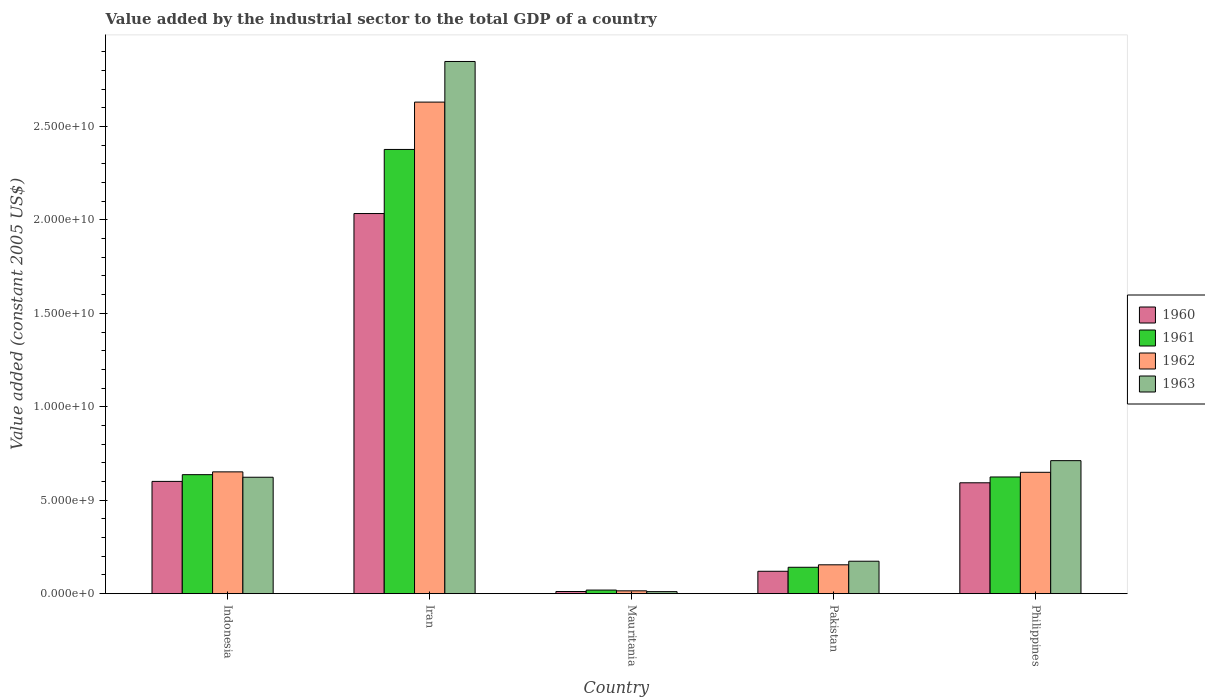How many groups of bars are there?
Make the answer very short. 5. Are the number of bars on each tick of the X-axis equal?
Ensure brevity in your answer.  Yes. What is the label of the 5th group of bars from the left?
Offer a terse response. Philippines. In how many cases, is the number of bars for a given country not equal to the number of legend labels?
Your answer should be compact. 0. What is the value added by the industrial sector in 1962 in Indonesia?
Keep it short and to the point. 6.52e+09. Across all countries, what is the maximum value added by the industrial sector in 1961?
Your answer should be compact. 2.38e+1. Across all countries, what is the minimum value added by the industrial sector in 1963?
Offer a terse response. 1.08e+08. In which country was the value added by the industrial sector in 1962 maximum?
Your response must be concise. Iran. In which country was the value added by the industrial sector in 1963 minimum?
Your response must be concise. Mauritania. What is the total value added by the industrial sector in 1961 in the graph?
Offer a terse response. 3.80e+1. What is the difference between the value added by the industrial sector in 1962 in Indonesia and that in Iran?
Your answer should be compact. -1.98e+1. What is the difference between the value added by the industrial sector in 1963 in Philippines and the value added by the industrial sector in 1960 in Iran?
Keep it short and to the point. -1.32e+1. What is the average value added by the industrial sector in 1963 per country?
Make the answer very short. 8.73e+09. What is the difference between the value added by the industrial sector of/in 1963 and value added by the industrial sector of/in 1961 in Mauritania?
Your response must be concise. -8.39e+07. In how many countries, is the value added by the industrial sector in 1961 greater than 1000000000 US$?
Offer a very short reply. 4. What is the ratio of the value added by the industrial sector in 1961 in Iran to that in Mauritania?
Provide a succinct answer. 123.7. Is the value added by the industrial sector in 1960 in Iran less than that in Philippines?
Provide a succinct answer. No. Is the difference between the value added by the industrial sector in 1963 in Pakistan and Philippines greater than the difference between the value added by the industrial sector in 1961 in Pakistan and Philippines?
Provide a succinct answer. No. What is the difference between the highest and the second highest value added by the industrial sector in 1962?
Offer a very short reply. -1.98e+1. What is the difference between the highest and the lowest value added by the industrial sector in 1963?
Ensure brevity in your answer.  2.84e+1. In how many countries, is the value added by the industrial sector in 1963 greater than the average value added by the industrial sector in 1963 taken over all countries?
Provide a succinct answer. 1. Is it the case that in every country, the sum of the value added by the industrial sector in 1960 and value added by the industrial sector in 1963 is greater than the sum of value added by the industrial sector in 1962 and value added by the industrial sector in 1961?
Make the answer very short. No. What does the 1st bar from the left in Indonesia represents?
Ensure brevity in your answer.  1960. Is it the case that in every country, the sum of the value added by the industrial sector in 1960 and value added by the industrial sector in 1962 is greater than the value added by the industrial sector in 1963?
Provide a succinct answer. Yes. How many bars are there?
Give a very brief answer. 20. What is the difference between two consecutive major ticks on the Y-axis?
Your answer should be very brief. 5.00e+09. Does the graph contain any zero values?
Your answer should be very brief. No. How are the legend labels stacked?
Ensure brevity in your answer.  Vertical. What is the title of the graph?
Keep it short and to the point. Value added by the industrial sector to the total GDP of a country. Does "2002" appear as one of the legend labels in the graph?
Your answer should be very brief. No. What is the label or title of the Y-axis?
Your answer should be very brief. Value added (constant 2005 US$). What is the Value added (constant 2005 US$) of 1960 in Indonesia?
Offer a very short reply. 6.01e+09. What is the Value added (constant 2005 US$) of 1961 in Indonesia?
Your response must be concise. 6.37e+09. What is the Value added (constant 2005 US$) of 1962 in Indonesia?
Make the answer very short. 6.52e+09. What is the Value added (constant 2005 US$) in 1963 in Indonesia?
Give a very brief answer. 6.23e+09. What is the Value added (constant 2005 US$) in 1960 in Iran?
Offer a very short reply. 2.03e+1. What is the Value added (constant 2005 US$) of 1961 in Iran?
Give a very brief answer. 2.38e+1. What is the Value added (constant 2005 US$) of 1962 in Iran?
Give a very brief answer. 2.63e+1. What is the Value added (constant 2005 US$) in 1963 in Iran?
Your response must be concise. 2.85e+1. What is the Value added (constant 2005 US$) in 1960 in Mauritania?
Give a very brief answer. 1.15e+08. What is the Value added (constant 2005 US$) in 1961 in Mauritania?
Your response must be concise. 1.92e+08. What is the Value added (constant 2005 US$) in 1962 in Mauritania?
Your answer should be compact. 1.51e+08. What is the Value added (constant 2005 US$) in 1963 in Mauritania?
Your response must be concise. 1.08e+08. What is the Value added (constant 2005 US$) in 1960 in Pakistan?
Provide a short and direct response. 1.20e+09. What is the Value added (constant 2005 US$) in 1961 in Pakistan?
Provide a short and direct response. 1.41e+09. What is the Value added (constant 2005 US$) of 1962 in Pakistan?
Provide a short and direct response. 1.54e+09. What is the Value added (constant 2005 US$) of 1963 in Pakistan?
Give a very brief answer. 1.74e+09. What is the Value added (constant 2005 US$) in 1960 in Philippines?
Offer a terse response. 5.93e+09. What is the Value added (constant 2005 US$) in 1961 in Philippines?
Provide a short and direct response. 6.24e+09. What is the Value added (constant 2005 US$) of 1962 in Philippines?
Offer a very short reply. 6.49e+09. What is the Value added (constant 2005 US$) of 1963 in Philippines?
Ensure brevity in your answer.  7.12e+09. Across all countries, what is the maximum Value added (constant 2005 US$) of 1960?
Your answer should be very brief. 2.03e+1. Across all countries, what is the maximum Value added (constant 2005 US$) in 1961?
Your response must be concise. 2.38e+1. Across all countries, what is the maximum Value added (constant 2005 US$) in 1962?
Keep it short and to the point. 2.63e+1. Across all countries, what is the maximum Value added (constant 2005 US$) in 1963?
Offer a very short reply. 2.85e+1. Across all countries, what is the minimum Value added (constant 2005 US$) in 1960?
Give a very brief answer. 1.15e+08. Across all countries, what is the minimum Value added (constant 2005 US$) in 1961?
Provide a succinct answer. 1.92e+08. Across all countries, what is the minimum Value added (constant 2005 US$) in 1962?
Your response must be concise. 1.51e+08. Across all countries, what is the minimum Value added (constant 2005 US$) in 1963?
Provide a short and direct response. 1.08e+08. What is the total Value added (constant 2005 US$) of 1960 in the graph?
Your answer should be very brief. 3.36e+1. What is the total Value added (constant 2005 US$) of 1961 in the graph?
Your answer should be very brief. 3.80e+1. What is the total Value added (constant 2005 US$) in 1962 in the graph?
Offer a very short reply. 4.10e+1. What is the total Value added (constant 2005 US$) in 1963 in the graph?
Offer a terse response. 4.37e+1. What is the difference between the Value added (constant 2005 US$) in 1960 in Indonesia and that in Iran?
Keep it short and to the point. -1.43e+1. What is the difference between the Value added (constant 2005 US$) in 1961 in Indonesia and that in Iran?
Give a very brief answer. -1.74e+1. What is the difference between the Value added (constant 2005 US$) of 1962 in Indonesia and that in Iran?
Make the answer very short. -1.98e+1. What is the difference between the Value added (constant 2005 US$) of 1963 in Indonesia and that in Iran?
Offer a terse response. -2.22e+1. What is the difference between the Value added (constant 2005 US$) in 1960 in Indonesia and that in Mauritania?
Offer a terse response. 5.89e+09. What is the difference between the Value added (constant 2005 US$) in 1961 in Indonesia and that in Mauritania?
Your response must be concise. 6.17e+09. What is the difference between the Value added (constant 2005 US$) of 1962 in Indonesia and that in Mauritania?
Offer a very short reply. 6.37e+09. What is the difference between the Value added (constant 2005 US$) in 1963 in Indonesia and that in Mauritania?
Your answer should be very brief. 6.12e+09. What is the difference between the Value added (constant 2005 US$) of 1960 in Indonesia and that in Pakistan?
Give a very brief answer. 4.81e+09. What is the difference between the Value added (constant 2005 US$) in 1961 in Indonesia and that in Pakistan?
Ensure brevity in your answer.  4.96e+09. What is the difference between the Value added (constant 2005 US$) in 1962 in Indonesia and that in Pakistan?
Provide a short and direct response. 4.97e+09. What is the difference between the Value added (constant 2005 US$) in 1963 in Indonesia and that in Pakistan?
Offer a terse response. 4.49e+09. What is the difference between the Value added (constant 2005 US$) of 1960 in Indonesia and that in Philippines?
Offer a very short reply. 7.44e+07. What is the difference between the Value added (constant 2005 US$) in 1961 in Indonesia and that in Philippines?
Your answer should be compact. 1.23e+08. What is the difference between the Value added (constant 2005 US$) in 1962 in Indonesia and that in Philippines?
Provide a short and direct response. 2.37e+07. What is the difference between the Value added (constant 2005 US$) of 1963 in Indonesia and that in Philippines?
Your response must be concise. -8.88e+08. What is the difference between the Value added (constant 2005 US$) in 1960 in Iran and that in Mauritania?
Your answer should be very brief. 2.02e+1. What is the difference between the Value added (constant 2005 US$) of 1961 in Iran and that in Mauritania?
Provide a short and direct response. 2.36e+1. What is the difference between the Value added (constant 2005 US$) of 1962 in Iran and that in Mauritania?
Your response must be concise. 2.62e+1. What is the difference between the Value added (constant 2005 US$) of 1963 in Iran and that in Mauritania?
Your answer should be compact. 2.84e+1. What is the difference between the Value added (constant 2005 US$) of 1960 in Iran and that in Pakistan?
Offer a very short reply. 1.91e+1. What is the difference between the Value added (constant 2005 US$) of 1961 in Iran and that in Pakistan?
Provide a short and direct response. 2.24e+1. What is the difference between the Value added (constant 2005 US$) in 1962 in Iran and that in Pakistan?
Provide a short and direct response. 2.48e+1. What is the difference between the Value added (constant 2005 US$) in 1963 in Iran and that in Pakistan?
Offer a very short reply. 2.67e+1. What is the difference between the Value added (constant 2005 US$) in 1960 in Iran and that in Philippines?
Provide a short and direct response. 1.44e+1. What is the difference between the Value added (constant 2005 US$) of 1961 in Iran and that in Philippines?
Your answer should be compact. 1.75e+1. What is the difference between the Value added (constant 2005 US$) of 1962 in Iran and that in Philippines?
Keep it short and to the point. 1.98e+1. What is the difference between the Value added (constant 2005 US$) of 1963 in Iran and that in Philippines?
Offer a terse response. 2.14e+1. What is the difference between the Value added (constant 2005 US$) in 1960 in Mauritania and that in Pakistan?
Your response must be concise. -1.08e+09. What is the difference between the Value added (constant 2005 US$) of 1961 in Mauritania and that in Pakistan?
Your answer should be very brief. -1.22e+09. What is the difference between the Value added (constant 2005 US$) of 1962 in Mauritania and that in Pakistan?
Your answer should be very brief. -1.39e+09. What is the difference between the Value added (constant 2005 US$) in 1963 in Mauritania and that in Pakistan?
Your answer should be very brief. -1.63e+09. What is the difference between the Value added (constant 2005 US$) of 1960 in Mauritania and that in Philippines?
Provide a succinct answer. -5.82e+09. What is the difference between the Value added (constant 2005 US$) in 1961 in Mauritania and that in Philippines?
Offer a very short reply. -6.05e+09. What is the difference between the Value added (constant 2005 US$) in 1962 in Mauritania and that in Philippines?
Provide a succinct answer. -6.34e+09. What is the difference between the Value added (constant 2005 US$) of 1963 in Mauritania and that in Philippines?
Offer a terse response. -7.01e+09. What is the difference between the Value added (constant 2005 US$) in 1960 in Pakistan and that in Philippines?
Give a very brief answer. -4.73e+09. What is the difference between the Value added (constant 2005 US$) of 1961 in Pakistan and that in Philippines?
Offer a very short reply. -4.83e+09. What is the difference between the Value added (constant 2005 US$) in 1962 in Pakistan and that in Philippines?
Offer a terse response. -4.95e+09. What is the difference between the Value added (constant 2005 US$) in 1963 in Pakistan and that in Philippines?
Offer a very short reply. -5.38e+09. What is the difference between the Value added (constant 2005 US$) in 1960 in Indonesia and the Value added (constant 2005 US$) in 1961 in Iran?
Give a very brief answer. -1.78e+1. What is the difference between the Value added (constant 2005 US$) in 1960 in Indonesia and the Value added (constant 2005 US$) in 1962 in Iran?
Your answer should be very brief. -2.03e+1. What is the difference between the Value added (constant 2005 US$) of 1960 in Indonesia and the Value added (constant 2005 US$) of 1963 in Iran?
Keep it short and to the point. -2.25e+1. What is the difference between the Value added (constant 2005 US$) in 1961 in Indonesia and the Value added (constant 2005 US$) in 1962 in Iran?
Provide a short and direct response. -1.99e+1. What is the difference between the Value added (constant 2005 US$) in 1961 in Indonesia and the Value added (constant 2005 US$) in 1963 in Iran?
Your response must be concise. -2.21e+1. What is the difference between the Value added (constant 2005 US$) in 1962 in Indonesia and the Value added (constant 2005 US$) in 1963 in Iran?
Offer a terse response. -2.20e+1. What is the difference between the Value added (constant 2005 US$) in 1960 in Indonesia and the Value added (constant 2005 US$) in 1961 in Mauritania?
Offer a terse response. 5.81e+09. What is the difference between the Value added (constant 2005 US$) of 1960 in Indonesia and the Value added (constant 2005 US$) of 1962 in Mauritania?
Give a very brief answer. 5.86e+09. What is the difference between the Value added (constant 2005 US$) of 1960 in Indonesia and the Value added (constant 2005 US$) of 1963 in Mauritania?
Provide a succinct answer. 5.90e+09. What is the difference between the Value added (constant 2005 US$) in 1961 in Indonesia and the Value added (constant 2005 US$) in 1962 in Mauritania?
Give a very brief answer. 6.22e+09. What is the difference between the Value added (constant 2005 US$) of 1961 in Indonesia and the Value added (constant 2005 US$) of 1963 in Mauritania?
Make the answer very short. 6.26e+09. What is the difference between the Value added (constant 2005 US$) in 1962 in Indonesia and the Value added (constant 2005 US$) in 1963 in Mauritania?
Provide a succinct answer. 6.41e+09. What is the difference between the Value added (constant 2005 US$) of 1960 in Indonesia and the Value added (constant 2005 US$) of 1961 in Pakistan?
Provide a short and direct response. 4.60e+09. What is the difference between the Value added (constant 2005 US$) of 1960 in Indonesia and the Value added (constant 2005 US$) of 1962 in Pakistan?
Make the answer very short. 4.46e+09. What is the difference between the Value added (constant 2005 US$) in 1960 in Indonesia and the Value added (constant 2005 US$) in 1963 in Pakistan?
Offer a very short reply. 4.27e+09. What is the difference between the Value added (constant 2005 US$) in 1961 in Indonesia and the Value added (constant 2005 US$) in 1962 in Pakistan?
Offer a very short reply. 4.82e+09. What is the difference between the Value added (constant 2005 US$) of 1961 in Indonesia and the Value added (constant 2005 US$) of 1963 in Pakistan?
Provide a succinct answer. 4.63e+09. What is the difference between the Value added (constant 2005 US$) of 1962 in Indonesia and the Value added (constant 2005 US$) of 1963 in Pakistan?
Provide a short and direct response. 4.78e+09. What is the difference between the Value added (constant 2005 US$) in 1960 in Indonesia and the Value added (constant 2005 US$) in 1961 in Philippines?
Ensure brevity in your answer.  -2.37e+08. What is the difference between the Value added (constant 2005 US$) of 1960 in Indonesia and the Value added (constant 2005 US$) of 1962 in Philippines?
Offer a very short reply. -4.86e+08. What is the difference between the Value added (constant 2005 US$) of 1960 in Indonesia and the Value added (constant 2005 US$) of 1963 in Philippines?
Provide a succinct answer. -1.11e+09. What is the difference between the Value added (constant 2005 US$) of 1961 in Indonesia and the Value added (constant 2005 US$) of 1962 in Philippines?
Give a very brief answer. -1.26e+08. What is the difference between the Value added (constant 2005 US$) of 1961 in Indonesia and the Value added (constant 2005 US$) of 1963 in Philippines?
Give a very brief answer. -7.50e+08. What is the difference between the Value added (constant 2005 US$) of 1962 in Indonesia and the Value added (constant 2005 US$) of 1963 in Philippines?
Your response must be concise. -6.01e+08. What is the difference between the Value added (constant 2005 US$) in 1960 in Iran and the Value added (constant 2005 US$) in 1961 in Mauritania?
Your response must be concise. 2.01e+1. What is the difference between the Value added (constant 2005 US$) of 1960 in Iran and the Value added (constant 2005 US$) of 1962 in Mauritania?
Your response must be concise. 2.02e+1. What is the difference between the Value added (constant 2005 US$) of 1960 in Iran and the Value added (constant 2005 US$) of 1963 in Mauritania?
Keep it short and to the point. 2.02e+1. What is the difference between the Value added (constant 2005 US$) in 1961 in Iran and the Value added (constant 2005 US$) in 1962 in Mauritania?
Ensure brevity in your answer.  2.36e+1. What is the difference between the Value added (constant 2005 US$) of 1961 in Iran and the Value added (constant 2005 US$) of 1963 in Mauritania?
Offer a very short reply. 2.37e+1. What is the difference between the Value added (constant 2005 US$) of 1962 in Iran and the Value added (constant 2005 US$) of 1963 in Mauritania?
Provide a short and direct response. 2.62e+1. What is the difference between the Value added (constant 2005 US$) of 1960 in Iran and the Value added (constant 2005 US$) of 1961 in Pakistan?
Offer a very short reply. 1.89e+1. What is the difference between the Value added (constant 2005 US$) in 1960 in Iran and the Value added (constant 2005 US$) in 1962 in Pakistan?
Offer a very short reply. 1.88e+1. What is the difference between the Value added (constant 2005 US$) of 1960 in Iran and the Value added (constant 2005 US$) of 1963 in Pakistan?
Keep it short and to the point. 1.86e+1. What is the difference between the Value added (constant 2005 US$) in 1961 in Iran and the Value added (constant 2005 US$) in 1962 in Pakistan?
Your answer should be compact. 2.22e+1. What is the difference between the Value added (constant 2005 US$) in 1961 in Iran and the Value added (constant 2005 US$) in 1963 in Pakistan?
Offer a terse response. 2.20e+1. What is the difference between the Value added (constant 2005 US$) in 1962 in Iran and the Value added (constant 2005 US$) in 1963 in Pakistan?
Your response must be concise. 2.46e+1. What is the difference between the Value added (constant 2005 US$) in 1960 in Iran and the Value added (constant 2005 US$) in 1961 in Philippines?
Make the answer very short. 1.41e+1. What is the difference between the Value added (constant 2005 US$) of 1960 in Iran and the Value added (constant 2005 US$) of 1962 in Philippines?
Offer a very short reply. 1.38e+1. What is the difference between the Value added (constant 2005 US$) in 1960 in Iran and the Value added (constant 2005 US$) in 1963 in Philippines?
Provide a succinct answer. 1.32e+1. What is the difference between the Value added (constant 2005 US$) of 1961 in Iran and the Value added (constant 2005 US$) of 1962 in Philippines?
Your response must be concise. 1.73e+1. What is the difference between the Value added (constant 2005 US$) in 1961 in Iran and the Value added (constant 2005 US$) in 1963 in Philippines?
Provide a short and direct response. 1.67e+1. What is the difference between the Value added (constant 2005 US$) of 1962 in Iran and the Value added (constant 2005 US$) of 1963 in Philippines?
Your answer should be compact. 1.92e+1. What is the difference between the Value added (constant 2005 US$) of 1960 in Mauritania and the Value added (constant 2005 US$) of 1961 in Pakistan?
Offer a very short reply. -1.30e+09. What is the difference between the Value added (constant 2005 US$) of 1960 in Mauritania and the Value added (constant 2005 US$) of 1962 in Pakistan?
Your answer should be very brief. -1.43e+09. What is the difference between the Value added (constant 2005 US$) in 1960 in Mauritania and the Value added (constant 2005 US$) in 1963 in Pakistan?
Ensure brevity in your answer.  -1.62e+09. What is the difference between the Value added (constant 2005 US$) in 1961 in Mauritania and the Value added (constant 2005 US$) in 1962 in Pakistan?
Ensure brevity in your answer.  -1.35e+09. What is the difference between the Value added (constant 2005 US$) in 1961 in Mauritania and the Value added (constant 2005 US$) in 1963 in Pakistan?
Offer a terse response. -1.54e+09. What is the difference between the Value added (constant 2005 US$) in 1962 in Mauritania and the Value added (constant 2005 US$) in 1963 in Pakistan?
Your response must be concise. -1.58e+09. What is the difference between the Value added (constant 2005 US$) in 1960 in Mauritania and the Value added (constant 2005 US$) in 1961 in Philippines?
Keep it short and to the point. -6.13e+09. What is the difference between the Value added (constant 2005 US$) of 1960 in Mauritania and the Value added (constant 2005 US$) of 1962 in Philippines?
Offer a terse response. -6.38e+09. What is the difference between the Value added (constant 2005 US$) of 1960 in Mauritania and the Value added (constant 2005 US$) of 1963 in Philippines?
Make the answer very short. -7.00e+09. What is the difference between the Value added (constant 2005 US$) of 1961 in Mauritania and the Value added (constant 2005 US$) of 1962 in Philippines?
Your answer should be very brief. -6.30e+09. What is the difference between the Value added (constant 2005 US$) of 1961 in Mauritania and the Value added (constant 2005 US$) of 1963 in Philippines?
Offer a terse response. -6.93e+09. What is the difference between the Value added (constant 2005 US$) of 1962 in Mauritania and the Value added (constant 2005 US$) of 1963 in Philippines?
Provide a short and direct response. -6.97e+09. What is the difference between the Value added (constant 2005 US$) of 1960 in Pakistan and the Value added (constant 2005 US$) of 1961 in Philippines?
Offer a very short reply. -5.05e+09. What is the difference between the Value added (constant 2005 US$) of 1960 in Pakistan and the Value added (constant 2005 US$) of 1962 in Philippines?
Provide a short and direct response. -5.30e+09. What is the difference between the Value added (constant 2005 US$) in 1960 in Pakistan and the Value added (constant 2005 US$) in 1963 in Philippines?
Provide a succinct answer. -5.92e+09. What is the difference between the Value added (constant 2005 US$) in 1961 in Pakistan and the Value added (constant 2005 US$) in 1962 in Philippines?
Offer a terse response. -5.08e+09. What is the difference between the Value added (constant 2005 US$) in 1961 in Pakistan and the Value added (constant 2005 US$) in 1963 in Philippines?
Your response must be concise. -5.71e+09. What is the difference between the Value added (constant 2005 US$) in 1962 in Pakistan and the Value added (constant 2005 US$) in 1963 in Philippines?
Your answer should be compact. -5.57e+09. What is the average Value added (constant 2005 US$) in 1960 per country?
Provide a short and direct response. 6.72e+09. What is the average Value added (constant 2005 US$) in 1961 per country?
Give a very brief answer. 7.60e+09. What is the average Value added (constant 2005 US$) of 1962 per country?
Your answer should be very brief. 8.20e+09. What is the average Value added (constant 2005 US$) in 1963 per country?
Ensure brevity in your answer.  8.73e+09. What is the difference between the Value added (constant 2005 US$) in 1960 and Value added (constant 2005 US$) in 1961 in Indonesia?
Make the answer very short. -3.60e+08. What is the difference between the Value added (constant 2005 US$) of 1960 and Value added (constant 2005 US$) of 1962 in Indonesia?
Give a very brief answer. -5.10e+08. What is the difference between the Value added (constant 2005 US$) in 1960 and Value added (constant 2005 US$) in 1963 in Indonesia?
Give a very brief answer. -2.22e+08. What is the difference between the Value added (constant 2005 US$) of 1961 and Value added (constant 2005 US$) of 1962 in Indonesia?
Your answer should be compact. -1.50e+08. What is the difference between the Value added (constant 2005 US$) of 1961 and Value added (constant 2005 US$) of 1963 in Indonesia?
Offer a terse response. 1.38e+08. What is the difference between the Value added (constant 2005 US$) in 1962 and Value added (constant 2005 US$) in 1963 in Indonesia?
Your answer should be very brief. 2.88e+08. What is the difference between the Value added (constant 2005 US$) in 1960 and Value added (constant 2005 US$) in 1961 in Iran?
Keep it short and to the point. -3.43e+09. What is the difference between the Value added (constant 2005 US$) of 1960 and Value added (constant 2005 US$) of 1962 in Iran?
Offer a terse response. -5.96e+09. What is the difference between the Value added (constant 2005 US$) of 1960 and Value added (constant 2005 US$) of 1963 in Iran?
Keep it short and to the point. -8.14e+09. What is the difference between the Value added (constant 2005 US$) of 1961 and Value added (constant 2005 US$) of 1962 in Iran?
Your answer should be very brief. -2.53e+09. What is the difference between the Value added (constant 2005 US$) in 1961 and Value added (constant 2005 US$) in 1963 in Iran?
Your answer should be compact. -4.71e+09. What is the difference between the Value added (constant 2005 US$) in 1962 and Value added (constant 2005 US$) in 1963 in Iran?
Provide a short and direct response. -2.17e+09. What is the difference between the Value added (constant 2005 US$) in 1960 and Value added (constant 2005 US$) in 1961 in Mauritania?
Your response must be concise. -7.68e+07. What is the difference between the Value added (constant 2005 US$) of 1960 and Value added (constant 2005 US$) of 1962 in Mauritania?
Your answer should be very brief. -3.59e+07. What is the difference between the Value added (constant 2005 US$) of 1960 and Value added (constant 2005 US$) of 1963 in Mauritania?
Your answer should be compact. 7.13e+06. What is the difference between the Value added (constant 2005 US$) of 1961 and Value added (constant 2005 US$) of 1962 in Mauritania?
Provide a succinct answer. 4.09e+07. What is the difference between the Value added (constant 2005 US$) of 1961 and Value added (constant 2005 US$) of 1963 in Mauritania?
Give a very brief answer. 8.39e+07. What is the difference between the Value added (constant 2005 US$) of 1962 and Value added (constant 2005 US$) of 1963 in Mauritania?
Your answer should be compact. 4.31e+07. What is the difference between the Value added (constant 2005 US$) of 1960 and Value added (constant 2005 US$) of 1961 in Pakistan?
Provide a succinct answer. -2.14e+08. What is the difference between the Value added (constant 2005 US$) in 1960 and Value added (constant 2005 US$) in 1962 in Pakistan?
Make the answer very short. -3.45e+08. What is the difference between the Value added (constant 2005 US$) in 1960 and Value added (constant 2005 US$) in 1963 in Pakistan?
Provide a short and direct response. -5.37e+08. What is the difference between the Value added (constant 2005 US$) in 1961 and Value added (constant 2005 US$) in 1962 in Pakistan?
Give a very brief answer. -1.32e+08. What is the difference between the Value added (constant 2005 US$) of 1961 and Value added (constant 2005 US$) of 1963 in Pakistan?
Your answer should be compact. -3.23e+08. What is the difference between the Value added (constant 2005 US$) in 1962 and Value added (constant 2005 US$) in 1963 in Pakistan?
Make the answer very short. -1.92e+08. What is the difference between the Value added (constant 2005 US$) in 1960 and Value added (constant 2005 US$) in 1961 in Philippines?
Ensure brevity in your answer.  -3.11e+08. What is the difference between the Value added (constant 2005 US$) of 1960 and Value added (constant 2005 US$) of 1962 in Philippines?
Provide a short and direct response. -5.61e+08. What is the difference between the Value added (constant 2005 US$) in 1960 and Value added (constant 2005 US$) in 1963 in Philippines?
Provide a succinct answer. -1.18e+09. What is the difference between the Value added (constant 2005 US$) in 1961 and Value added (constant 2005 US$) in 1962 in Philippines?
Provide a succinct answer. -2.50e+08. What is the difference between the Value added (constant 2005 US$) in 1961 and Value added (constant 2005 US$) in 1963 in Philippines?
Provide a short and direct response. -8.74e+08. What is the difference between the Value added (constant 2005 US$) in 1962 and Value added (constant 2005 US$) in 1963 in Philippines?
Offer a very short reply. -6.24e+08. What is the ratio of the Value added (constant 2005 US$) of 1960 in Indonesia to that in Iran?
Offer a very short reply. 0.3. What is the ratio of the Value added (constant 2005 US$) of 1961 in Indonesia to that in Iran?
Offer a terse response. 0.27. What is the ratio of the Value added (constant 2005 US$) of 1962 in Indonesia to that in Iran?
Give a very brief answer. 0.25. What is the ratio of the Value added (constant 2005 US$) of 1963 in Indonesia to that in Iran?
Your response must be concise. 0.22. What is the ratio of the Value added (constant 2005 US$) in 1960 in Indonesia to that in Mauritania?
Provide a short and direct response. 52.07. What is the ratio of the Value added (constant 2005 US$) in 1961 in Indonesia to that in Mauritania?
Ensure brevity in your answer.  33.14. What is the ratio of the Value added (constant 2005 US$) in 1962 in Indonesia to that in Mauritania?
Offer a very short reply. 43.07. What is the ratio of the Value added (constant 2005 US$) in 1963 in Indonesia to that in Mauritania?
Provide a succinct answer. 57.56. What is the ratio of the Value added (constant 2005 US$) of 1960 in Indonesia to that in Pakistan?
Offer a very short reply. 5.01. What is the ratio of the Value added (constant 2005 US$) in 1961 in Indonesia to that in Pakistan?
Ensure brevity in your answer.  4.51. What is the ratio of the Value added (constant 2005 US$) in 1962 in Indonesia to that in Pakistan?
Your response must be concise. 4.22. What is the ratio of the Value added (constant 2005 US$) in 1963 in Indonesia to that in Pakistan?
Make the answer very short. 3.59. What is the ratio of the Value added (constant 2005 US$) in 1960 in Indonesia to that in Philippines?
Your answer should be very brief. 1.01. What is the ratio of the Value added (constant 2005 US$) of 1961 in Indonesia to that in Philippines?
Your response must be concise. 1.02. What is the ratio of the Value added (constant 2005 US$) in 1962 in Indonesia to that in Philippines?
Give a very brief answer. 1. What is the ratio of the Value added (constant 2005 US$) of 1963 in Indonesia to that in Philippines?
Your answer should be very brief. 0.88. What is the ratio of the Value added (constant 2005 US$) of 1960 in Iran to that in Mauritania?
Provide a short and direct response. 176.32. What is the ratio of the Value added (constant 2005 US$) of 1961 in Iran to that in Mauritania?
Give a very brief answer. 123.7. What is the ratio of the Value added (constant 2005 US$) in 1962 in Iran to that in Mauritania?
Keep it short and to the point. 173.84. What is the ratio of the Value added (constant 2005 US$) of 1963 in Iran to that in Mauritania?
Your answer should be very brief. 263.11. What is the ratio of the Value added (constant 2005 US$) of 1960 in Iran to that in Pakistan?
Offer a terse response. 16.98. What is the ratio of the Value added (constant 2005 US$) of 1961 in Iran to that in Pakistan?
Offer a very short reply. 16.84. What is the ratio of the Value added (constant 2005 US$) in 1962 in Iran to that in Pakistan?
Your answer should be compact. 17.04. What is the ratio of the Value added (constant 2005 US$) of 1963 in Iran to that in Pakistan?
Make the answer very short. 16.41. What is the ratio of the Value added (constant 2005 US$) of 1960 in Iran to that in Philippines?
Your response must be concise. 3.43. What is the ratio of the Value added (constant 2005 US$) in 1961 in Iran to that in Philippines?
Ensure brevity in your answer.  3.81. What is the ratio of the Value added (constant 2005 US$) in 1962 in Iran to that in Philippines?
Provide a short and direct response. 4.05. What is the ratio of the Value added (constant 2005 US$) in 1963 in Iran to that in Philippines?
Provide a succinct answer. 4. What is the ratio of the Value added (constant 2005 US$) in 1960 in Mauritania to that in Pakistan?
Provide a short and direct response. 0.1. What is the ratio of the Value added (constant 2005 US$) in 1961 in Mauritania to that in Pakistan?
Offer a very short reply. 0.14. What is the ratio of the Value added (constant 2005 US$) in 1962 in Mauritania to that in Pakistan?
Keep it short and to the point. 0.1. What is the ratio of the Value added (constant 2005 US$) of 1963 in Mauritania to that in Pakistan?
Keep it short and to the point. 0.06. What is the ratio of the Value added (constant 2005 US$) in 1960 in Mauritania to that in Philippines?
Ensure brevity in your answer.  0.02. What is the ratio of the Value added (constant 2005 US$) of 1961 in Mauritania to that in Philippines?
Offer a terse response. 0.03. What is the ratio of the Value added (constant 2005 US$) of 1962 in Mauritania to that in Philippines?
Offer a very short reply. 0.02. What is the ratio of the Value added (constant 2005 US$) in 1963 in Mauritania to that in Philippines?
Offer a terse response. 0.02. What is the ratio of the Value added (constant 2005 US$) of 1960 in Pakistan to that in Philippines?
Make the answer very short. 0.2. What is the ratio of the Value added (constant 2005 US$) of 1961 in Pakistan to that in Philippines?
Ensure brevity in your answer.  0.23. What is the ratio of the Value added (constant 2005 US$) in 1962 in Pakistan to that in Philippines?
Give a very brief answer. 0.24. What is the ratio of the Value added (constant 2005 US$) in 1963 in Pakistan to that in Philippines?
Make the answer very short. 0.24. What is the difference between the highest and the second highest Value added (constant 2005 US$) in 1960?
Make the answer very short. 1.43e+1. What is the difference between the highest and the second highest Value added (constant 2005 US$) in 1961?
Your answer should be compact. 1.74e+1. What is the difference between the highest and the second highest Value added (constant 2005 US$) of 1962?
Give a very brief answer. 1.98e+1. What is the difference between the highest and the second highest Value added (constant 2005 US$) in 1963?
Your answer should be compact. 2.14e+1. What is the difference between the highest and the lowest Value added (constant 2005 US$) in 1960?
Ensure brevity in your answer.  2.02e+1. What is the difference between the highest and the lowest Value added (constant 2005 US$) in 1961?
Make the answer very short. 2.36e+1. What is the difference between the highest and the lowest Value added (constant 2005 US$) of 1962?
Keep it short and to the point. 2.62e+1. What is the difference between the highest and the lowest Value added (constant 2005 US$) of 1963?
Give a very brief answer. 2.84e+1. 